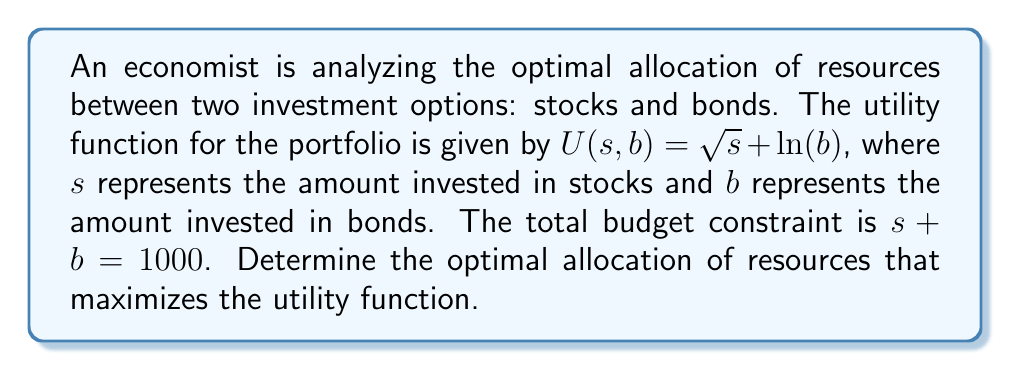Help me with this question. To solve this problem, we'll use the method of Lagrange multipliers:

1) Define the Lagrangian function:
   $$L(s,b,\lambda) = \sqrt{s} + \ln(b) - \lambda(s + b - 1000)$$

2) Take partial derivatives and set them equal to zero:
   $$\frac{\partial L}{\partial s} = \frac{1}{2\sqrt{s}} - \lambda = 0$$
   $$\frac{\partial L}{\partial b} = \frac{1}{b} - \lambda = 0$$
   $$\frac{\partial L}{\partial \lambda} = s + b - 1000 = 0$$

3) From the first two equations:
   $$\frac{1}{2\sqrt{s}} = \lambda = \frac{1}{b}$$

4) This implies:
   $$b = 2\sqrt{s}$$

5) Substitute this into the budget constraint:
   $$s + 2\sqrt{s} = 1000$$

6) Solve this equation:
   Let $\sqrt{s} = x$, then $x^2 + 2x - 1000 = 0$
   Using the quadratic formula: $x = \frac{-2 \pm \sqrt{4 + 4000}}{2} = -1 + \sqrt{1001}$
   
   Taking the positive root (as $s$ must be positive):
   $$\sqrt{s} = -1 + \sqrt{1001}$$
   $$s = (-1 + \sqrt{1001})^2 \approx 666.67$$

7) Calculate $b$:
   $$b = 1000 - s \approx 333.33$$

Therefore, the optimal allocation is approximately $666.67 in stocks and $333.33 in bonds.
Answer: $s \approx 666.67$, $b \approx 333.33$ 